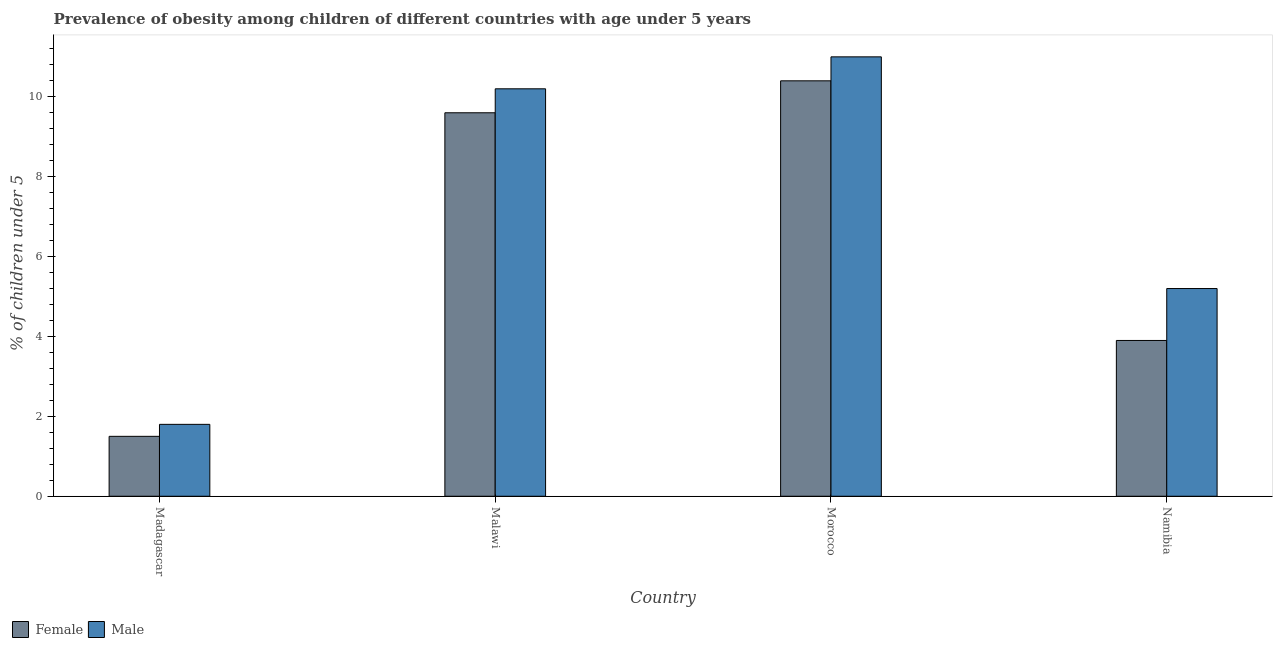Are the number of bars per tick equal to the number of legend labels?
Give a very brief answer. Yes. How many bars are there on the 4th tick from the left?
Your answer should be very brief. 2. What is the label of the 3rd group of bars from the left?
Give a very brief answer. Morocco. In how many cases, is the number of bars for a given country not equal to the number of legend labels?
Provide a short and direct response. 0. What is the percentage of obese male children in Madagascar?
Make the answer very short. 1.8. Across all countries, what is the maximum percentage of obese male children?
Make the answer very short. 11. Across all countries, what is the minimum percentage of obese male children?
Offer a terse response. 1.8. In which country was the percentage of obese female children maximum?
Make the answer very short. Morocco. In which country was the percentage of obese female children minimum?
Provide a short and direct response. Madagascar. What is the total percentage of obese male children in the graph?
Offer a terse response. 28.2. What is the difference between the percentage of obese female children in Madagascar and that in Malawi?
Your answer should be compact. -8.1. What is the difference between the percentage of obese female children in Malawi and the percentage of obese male children in Namibia?
Your answer should be very brief. 4.4. What is the average percentage of obese male children per country?
Keep it short and to the point. 7.05. What is the difference between the percentage of obese female children and percentage of obese male children in Madagascar?
Your answer should be very brief. -0.3. What is the ratio of the percentage of obese male children in Malawi to that in Namibia?
Make the answer very short. 1.96. Is the percentage of obese male children in Morocco less than that in Namibia?
Make the answer very short. No. What is the difference between the highest and the second highest percentage of obese female children?
Offer a terse response. 0.8. What is the difference between the highest and the lowest percentage of obese female children?
Ensure brevity in your answer.  8.9. Is the sum of the percentage of obese male children in Morocco and Namibia greater than the maximum percentage of obese female children across all countries?
Provide a short and direct response. Yes. What does the 2nd bar from the left in Madagascar represents?
Offer a terse response. Male. How many bars are there?
Give a very brief answer. 8. How many countries are there in the graph?
Your answer should be very brief. 4. Are the values on the major ticks of Y-axis written in scientific E-notation?
Give a very brief answer. No. Does the graph contain grids?
Give a very brief answer. No. How are the legend labels stacked?
Keep it short and to the point. Horizontal. What is the title of the graph?
Your answer should be very brief. Prevalence of obesity among children of different countries with age under 5 years. Does "Unregistered firms" appear as one of the legend labels in the graph?
Make the answer very short. No. What is the label or title of the Y-axis?
Offer a very short reply.  % of children under 5. What is the  % of children under 5 in Female in Madagascar?
Give a very brief answer. 1.5. What is the  % of children under 5 of Male in Madagascar?
Offer a very short reply. 1.8. What is the  % of children under 5 in Female in Malawi?
Give a very brief answer. 9.6. What is the  % of children under 5 of Male in Malawi?
Keep it short and to the point. 10.2. What is the  % of children under 5 in Female in Morocco?
Keep it short and to the point. 10.4. What is the  % of children under 5 in Female in Namibia?
Offer a terse response. 3.9. What is the  % of children under 5 in Male in Namibia?
Ensure brevity in your answer.  5.2. Across all countries, what is the maximum  % of children under 5 of Female?
Offer a very short reply. 10.4. Across all countries, what is the minimum  % of children under 5 of Male?
Keep it short and to the point. 1.8. What is the total  % of children under 5 in Female in the graph?
Your answer should be compact. 25.4. What is the total  % of children under 5 in Male in the graph?
Offer a very short reply. 28.2. What is the difference between the  % of children under 5 in Female in Madagascar and that in Morocco?
Keep it short and to the point. -8.9. What is the difference between the  % of children under 5 in Male in Madagascar and that in Namibia?
Your answer should be compact. -3.4. What is the difference between the  % of children under 5 of Female in Malawi and that in Morocco?
Make the answer very short. -0.8. What is the difference between the  % of children under 5 in Male in Malawi and that in Morocco?
Your response must be concise. -0.8. What is the difference between the  % of children under 5 in Female in Malawi and that in Namibia?
Ensure brevity in your answer.  5.7. What is the difference between the  % of children under 5 of Female in Morocco and that in Namibia?
Keep it short and to the point. 6.5. What is the difference between the  % of children under 5 in Male in Morocco and that in Namibia?
Make the answer very short. 5.8. What is the difference between the  % of children under 5 of Female in Madagascar and the  % of children under 5 of Male in Morocco?
Give a very brief answer. -9.5. What is the difference between the  % of children under 5 in Female in Madagascar and the  % of children under 5 in Male in Namibia?
Ensure brevity in your answer.  -3.7. What is the difference between the  % of children under 5 of Female in Malawi and the  % of children under 5 of Male in Morocco?
Keep it short and to the point. -1.4. What is the difference between the  % of children under 5 in Female in Malawi and the  % of children under 5 in Male in Namibia?
Provide a short and direct response. 4.4. What is the difference between the  % of children under 5 of Female in Morocco and the  % of children under 5 of Male in Namibia?
Provide a short and direct response. 5.2. What is the average  % of children under 5 in Female per country?
Give a very brief answer. 6.35. What is the average  % of children under 5 of Male per country?
Your response must be concise. 7.05. What is the difference between the  % of children under 5 in Female and  % of children under 5 in Male in Madagascar?
Your answer should be compact. -0.3. What is the difference between the  % of children under 5 in Female and  % of children under 5 in Male in Namibia?
Your response must be concise. -1.3. What is the ratio of the  % of children under 5 of Female in Madagascar to that in Malawi?
Offer a terse response. 0.16. What is the ratio of the  % of children under 5 in Male in Madagascar to that in Malawi?
Offer a very short reply. 0.18. What is the ratio of the  % of children under 5 of Female in Madagascar to that in Morocco?
Provide a succinct answer. 0.14. What is the ratio of the  % of children under 5 of Male in Madagascar to that in Morocco?
Make the answer very short. 0.16. What is the ratio of the  % of children under 5 of Female in Madagascar to that in Namibia?
Your response must be concise. 0.38. What is the ratio of the  % of children under 5 of Male in Madagascar to that in Namibia?
Your answer should be compact. 0.35. What is the ratio of the  % of children under 5 of Female in Malawi to that in Morocco?
Make the answer very short. 0.92. What is the ratio of the  % of children under 5 of Male in Malawi to that in Morocco?
Ensure brevity in your answer.  0.93. What is the ratio of the  % of children under 5 of Female in Malawi to that in Namibia?
Provide a short and direct response. 2.46. What is the ratio of the  % of children under 5 in Male in Malawi to that in Namibia?
Provide a succinct answer. 1.96. What is the ratio of the  % of children under 5 of Female in Morocco to that in Namibia?
Provide a succinct answer. 2.67. What is the ratio of the  % of children under 5 of Male in Morocco to that in Namibia?
Provide a succinct answer. 2.12. 